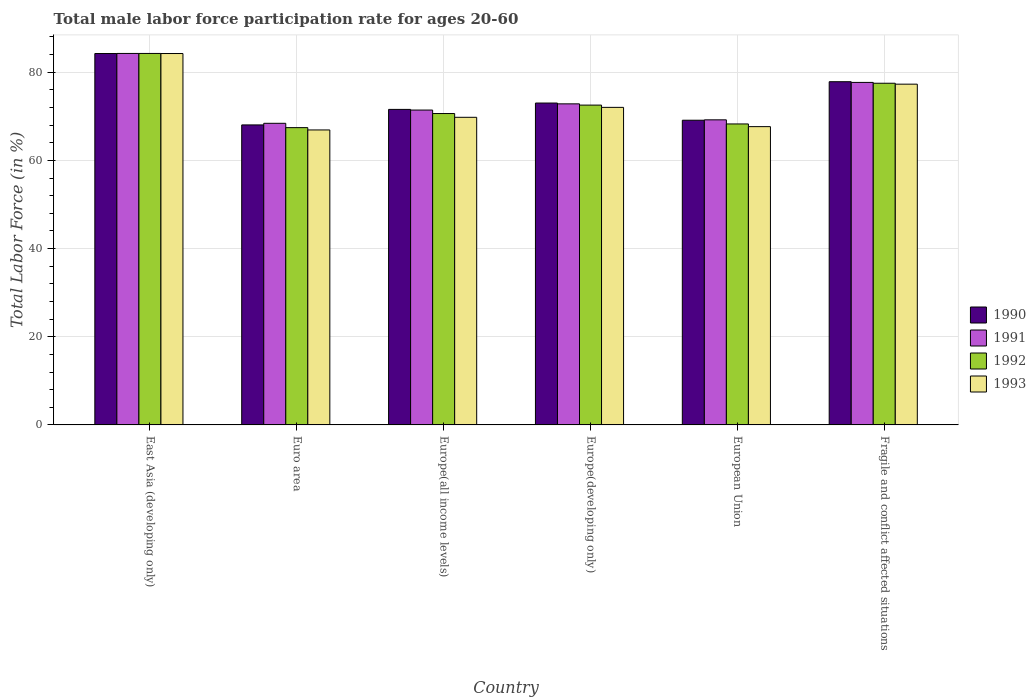How many groups of bars are there?
Your answer should be compact. 6. Are the number of bars per tick equal to the number of legend labels?
Your response must be concise. Yes. How many bars are there on the 6th tick from the left?
Offer a very short reply. 4. How many bars are there on the 6th tick from the right?
Make the answer very short. 4. What is the label of the 5th group of bars from the left?
Provide a succinct answer. European Union. What is the male labor force participation rate in 1991 in Europe(all income levels)?
Make the answer very short. 71.41. Across all countries, what is the maximum male labor force participation rate in 1991?
Your answer should be very brief. 84.25. Across all countries, what is the minimum male labor force participation rate in 1991?
Keep it short and to the point. 68.4. In which country was the male labor force participation rate in 1993 maximum?
Give a very brief answer. East Asia (developing only). What is the total male labor force participation rate in 1993 in the graph?
Ensure brevity in your answer.  437.85. What is the difference between the male labor force participation rate in 1990 in Europe(developing only) and that in Fragile and conflict affected situations?
Offer a very short reply. -4.84. What is the difference between the male labor force participation rate in 1991 in European Union and the male labor force participation rate in 1993 in Europe(all income levels)?
Your answer should be very brief. -0.57. What is the average male labor force participation rate in 1991 per country?
Ensure brevity in your answer.  73.96. What is the difference between the male labor force participation rate of/in 1993 and male labor force participation rate of/in 1992 in Europe(developing only)?
Ensure brevity in your answer.  -0.51. In how many countries, is the male labor force participation rate in 1993 greater than 64 %?
Keep it short and to the point. 6. What is the ratio of the male labor force participation rate in 1993 in East Asia (developing only) to that in Europe(developing only)?
Offer a terse response. 1.17. Is the difference between the male labor force participation rate in 1993 in Europe(developing only) and European Union greater than the difference between the male labor force participation rate in 1992 in Europe(developing only) and European Union?
Provide a short and direct response. Yes. What is the difference between the highest and the second highest male labor force participation rate in 1991?
Make the answer very short. -11.43. What is the difference between the highest and the lowest male labor force participation rate in 1990?
Make the answer very short. 16.19. Is it the case that in every country, the sum of the male labor force participation rate in 1990 and male labor force participation rate in 1993 is greater than the sum of male labor force participation rate in 1992 and male labor force participation rate in 1991?
Make the answer very short. No. How many bars are there?
Provide a short and direct response. 24. Are the values on the major ticks of Y-axis written in scientific E-notation?
Your answer should be compact. No. What is the title of the graph?
Keep it short and to the point. Total male labor force participation rate for ages 20-60. What is the label or title of the X-axis?
Provide a short and direct response. Country. What is the label or title of the Y-axis?
Provide a succinct answer. Total Labor Force (in %). What is the Total Labor Force (in %) of 1990 in East Asia (developing only)?
Make the answer very short. 84.23. What is the Total Labor Force (in %) in 1991 in East Asia (developing only)?
Provide a short and direct response. 84.25. What is the Total Labor Force (in %) of 1992 in East Asia (developing only)?
Ensure brevity in your answer.  84.25. What is the Total Labor Force (in %) of 1993 in East Asia (developing only)?
Provide a succinct answer. 84.23. What is the Total Labor Force (in %) in 1990 in Euro area?
Ensure brevity in your answer.  68.04. What is the Total Labor Force (in %) of 1991 in Euro area?
Make the answer very short. 68.4. What is the Total Labor Force (in %) of 1992 in Euro area?
Offer a terse response. 67.42. What is the Total Labor Force (in %) of 1993 in Euro area?
Keep it short and to the point. 66.9. What is the Total Labor Force (in %) in 1990 in Europe(all income levels)?
Provide a succinct answer. 71.56. What is the Total Labor Force (in %) of 1991 in Europe(all income levels)?
Give a very brief answer. 71.41. What is the Total Labor Force (in %) in 1992 in Europe(all income levels)?
Provide a short and direct response. 70.62. What is the Total Labor Force (in %) in 1993 in Europe(all income levels)?
Provide a succinct answer. 69.76. What is the Total Labor Force (in %) in 1990 in Europe(developing only)?
Make the answer very short. 73. What is the Total Labor Force (in %) of 1991 in Europe(developing only)?
Give a very brief answer. 72.82. What is the Total Labor Force (in %) in 1992 in Europe(developing only)?
Provide a succinct answer. 72.53. What is the Total Labor Force (in %) of 1993 in Europe(developing only)?
Ensure brevity in your answer.  72.02. What is the Total Labor Force (in %) of 1990 in European Union?
Make the answer very short. 69.1. What is the Total Labor Force (in %) in 1991 in European Union?
Give a very brief answer. 69.19. What is the Total Labor Force (in %) in 1992 in European Union?
Your response must be concise. 68.26. What is the Total Labor Force (in %) of 1993 in European Union?
Your response must be concise. 67.65. What is the Total Labor Force (in %) of 1990 in Fragile and conflict affected situations?
Keep it short and to the point. 77.84. What is the Total Labor Force (in %) of 1991 in Fragile and conflict affected situations?
Provide a short and direct response. 77.68. What is the Total Labor Force (in %) in 1992 in Fragile and conflict affected situations?
Your answer should be compact. 77.49. What is the Total Labor Force (in %) of 1993 in Fragile and conflict affected situations?
Your response must be concise. 77.28. Across all countries, what is the maximum Total Labor Force (in %) of 1990?
Offer a terse response. 84.23. Across all countries, what is the maximum Total Labor Force (in %) of 1991?
Provide a succinct answer. 84.25. Across all countries, what is the maximum Total Labor Force (in %) in 1992?
Ensure brevity in your answer.  84.25. Across all countries, what is the maximum Total Labor Force (in %) in 1993?
Your response must be concise. 84.23. Across all countries, what is the minimum Total Labor Force (in %) of 1990?
Provide a short and direct response. 68.04. Across all countries, what is the minimum Total Labor Force (in %) in 1991?
Ensure brevity in your answer.  68.4. Across all countries, what is the minimum Total Labor Force (in %) of 1992?
Your answer should be compact. 67.42. Across all countries, what is the minimum Total Labor Force (in %) of 1993?
Your response must be concise. 66.9. What is the total Total Labor Force (in %) in 1990 in the graph?
Your response must be concise. 443.78. What is the total Total Labor Force (in %) of 1991 in the graph?
Keep it short and to the point. 443.75. What is the total Total Labor Force (in %) in 1992 in the graph?
Your answer should be compact. 440.58. What is the total Total Labor Force (in %) of 1993 in the graph?
Offer a terse response. 437.85. What is the difference between the Total Labor Force (in %) of 1990 in East Asia (developing only) and that in Euro area?
Your answer should be very brief. 16.19. What is the difference between the Total Labor Force (in %) of 1991 in East Asia (developing only) and that in Euro area?
Make the answer very short. 15.84. What is the difference between the Total Labor Force (in %) of 1992 in East Asia (developing only) and that in Euro area?
Provide a short and direct response. 16.83. What is the difference between the Total Labor Force (in %) of 1993 in East Asia (developing only) and that in Euro area?
Your response must be concise. 17.34. What is the difference between the Total Labor Force (in %) of 1990 in East Asia (developing only) and that in Europe(all income levels)?
Offer a very short reply. 12.67. What is the difference between the Total Labor Force (in %) of 1991 in East Asia (developing only) and that in Europe(all income levels)?
Provide a succinct answer. 12.84. What is the difference between the Total Labor Force (in %) in 1992 in East Asia (developing only) and that in Europe(all income levels)?
Make the answer very short. 13.63. What is the difference between the Total Labor Force (in %) in 1993 in East Asia (developing only) and that in Europe(all income levels)?
Your answer should be very brief. 14.47. What is the difference between the Total Labor Force (in %) in 1990 in East Asia (developing only) and that in Europe(developing only)?
Provide a short and direct response. 11.23. What is the difference between the Total Labor Force (in %) of 1991 in East Asia (developing only) and that in Europe(developing only)?
Your response must be concise. 11.43. What is the difference between the Total Labor Force (in %) in 1992 in East Asia (developing only) and that in Europe(developing only)?
Give a very brief answer. 11.71. What is the difference between the Total Labor Force (in %) of 1993 in East Asia (developing only) and that in Europe(developing only)?
Your answer should be compact. 12.21. What is the difference between the Total Labor Force (in %) of 1990 in East Asia (developing only) and that in European Union?
Provide a short and direct response. 15.13. What is the difference between the Total Labor Force (in %) in 1991 in East Asia (developing only) and that in European Union?
Give a very brief answer. 15.05. What is the difference between the Total Labor Force (in %) of 1992 in East Asia (developing only) and that in European Union?
Your response must be concise. 15.99. What is the difference between the Total Labor Force (in %) in 1993 in East Asia (developing only) and that in European Union?
Your answer should be compact. 16.58. What is the difference between the Total Labor Force (in %) of 1990 in East Asia (developing only) and that in Fragile and conflict affected situations?
Ensure brevity in your answer.  6.39. What is the difference between the Total Labor Force (in %) in 1991 in East Asia (developing only) and that in Fragile and conflict affected situations?
Your response must be concise. 6.57. What is the difference between the Total Labor Force (in %) in 1992 in East Asia (developing only) and that in Fragile and conflict affected situations?
Ensure brevity in your answer.  6.76. What is the difference between the Total Labor Force (in %) of 1993 in East Asia (developing only) and that in Fragile and conflict affected situations?
Make the answer very short. 6.95. What is the difference between the Total Labor Force (in %) of 1990 in Euro area and that in Europe(all income levels)?
Keep it short and to the point. -3.52. What is the difference between the Total Labor Force (in %) of 1991 in Euro area and that in Europe(all income levels)?
Keep it short and to the point. -3. What is the difference between the Total Labor Force (in %) in 1992 in Euro area and that in Europe(all income levels)?
Your answer should be very brief. -3.2. What is the difference between the Total Labor Force (in %) of 1993 in Euro area and that in Europe(all income levels)?
Make the answer very short. -2.87. What is the difference between the Total Labor Force (in %) of 1990 in Euro area and that in Europe(developing only)?
Your response must be concise. -4.96. What is the difference between the Total Labor Force (in %) of 1991 in Euro area and that in Europe(developing only)?
Your response must be concise. -4.41. What is the difference between the Total Labor Force (in %) of 1992 in Euro area and that in Europe(developing only)?
Provide a succinct answer. -5.11. What is the difference between the Total Labor Force (in %) of 1993 in Euro area and that in Europe(developing only)?
Your answer should be very brief. -5.12. What is the difference between the Total Labor Force (in %) of 1990 in Euro area and that in European Union?
Your answer should be very brief. -1.06. What is the difference between the Total Labor Force (in %) of 1991 in Euro area and that in European Union?
Make the answer very short. -0.79. What is the difference between the Total Labor Force (in %) in 1992 in Euro area and that in European Union?
Offer a terse response. -0.83. What is the difference between the Total Labor Force (in %) in 1993 in Euro area and that in European Union?
Your response must be concise. -0.75. What is the difference between the Total Labor Force (in %) in 1990 in Euro area and that in Fragile and conflict affected situations?
Keep it short and to the point. -9.8. What is the difference between the Total Labor Force (in %) in 1991 in Euro area and that in Fragile and conflict affected situations?
Offer a terse response. -9.27. What is the difference between the Total Labor Force (in %) in 1992 in Euro area and that in Fragile and conflict affected situations?
Give a very brief answer. -10.07. What is the difference between the Total Labor Force (in %) in 1993 in Euro area and that in Fragile and conflict affected situations?
Provide a succinct answer. -10.38. What is the difference between the Total Labor Force (in %) in 1990 in Europe(all income levels) and that in Europe(developing only)?
Provide a short and direct response. -1.44. What is the difference between the Total Labor Force (in %) of 1991 in Europe(all income levels) and that in Europe(developing only)?
Ensure brevity in your answer.  -1.41. What is the difference between the Total Labor Force (in %) in 1992 in Europe(all income levels) and that in Europe(developing only)?
Your answer should be very brief. -1.91. What is the difference between the Total Labor Force (in %) of 1993 in Europe(all income levels) and that in Europe(developing only)?
Keep it short and to the point. -2.26. What is the difference between the Total Labor Force (in %) in 1990 in Europe(all income levels) and that in European Union?
Your answer should be very brief. 2.46. What is the difference between the Total Labor Force (in %) in 1991 in Europe(all income levels) and that in European Union?
Provide a short and direct response. 2.22. What is the difference between the Total Labor Force (in %) in 1992 in Europe(all income levels) and that in European Union?
Give a very brief answer. 2.36. What is the difference between the Total Labor Force (in %) of 1993 in Europe(all income levels) and that in European Union?
Your response must be concise. 2.11. What is the difference between the Total Labor Force (in %) of 1990 in Europe(all income levels) and that in Fragile and conflict affected situations?
Offer a terse response. -6.28. What is the difference between the Total Labor Force (in %) in 1991 in Europe(all income levels) and that in Fragile and conflict affected situations?
Provide a succinct answer. -6.27. What is the difference between the Total Labor Force (in %) of 1992 in Europe(all income levels) and that in Fragile and conflict affected situations?
Offer a very short reply. -6.87. What is the difference between the Total Labor Force (in %) of 1993 in Europe(all income levels) and that in Fragile and conflict affected situations?
Ensure brevity in your answer.  -7.52. What is the difference between the Total Labor Force (in %) in 1990 in Europe(developing only) and that in European Union?
Your response must be concise. 3.9. What is the difference between the Total Labor Force (in %) in 1991 in Europe(developing only) and that in European Union?
Give a very brief answer. 3.62. What is the difference between the Total Labor Force (in %) of 1992 in Europe(developing only) and that in European Union?
Ensure brevity in your answer.  4.28. What is the difference between the Total Labor Force (in %) of 1993 in Europe(developing only) and that in European Union?
Give a very brief answer. 4.37. What is the difference between the Total Labor Force (in %) in 1990 in Europe(developing only) and that in Fragile and conflict affected situations?
Your answer should be compact. -4.84. What is the difference between the Total Labor Force (in %) of 1991 in Europe(developing only) and that in Fragile and conflict affected situations?
Your answer should be compact. -4.86. What is the difference between the Total Labor Force (in %) in 1992 in Europe(developing only) and that in Fragile and conflict affected situations?
Provide a succinct answer. -4.96. What is the difference between the Total Labor Force (in %) in 1993 in Europe(developing only) and that in Fragile and conflict affected situations?
Your response must be concise. -5.26. What is the difference between the Total Labor Force (in %) in 1990 in European Union and that in Fragile and conflict affected situations?
Your response must be concise. -8.73. What is the difference between the Total Labor Force (in %) in 1991 in European Union and that in Fragile and conflict affected situations?
Offer a very short reply. -8.49. What is the difference between the Total Labor Force (in %) of 1992 in European Union and that in Fragile and conflict affected situations?
Ensure brevity in your answer.  -9.23. What is the difference between the Total Labor Force (in %) of 1993 in European Union and that in Fragile and conflict affected situations?
Give a very brief answer. -9.63. What is the difference between the Total Labor Force (in %) in 1990 in East Asia (developing only) and the Total Labor Force (in %) in 1991 in Euro area?
Your answer should be compact. 15.83. What is the difference between the Total Labor Force (in %) of 1990 in East Asia (developing only) and the Total Labor Force (in %) of 1992 in Euro area?
Offer a terse response. 16.81. What is the difference between the Total Labor Force (in %) in 1990 in East Asia (developing only) and the Total Labor Force (in %) in 1993 in Euro area?
Offer a terse response. 17.34. What is the difference between the Total Labor Force (in %) in 1991 in East Asia (developing only) and the Total Labor Force (in %) in 1992 in Euro area?
Your response must be concise. 16.82. What is the difference between the Total Labor Force (in %) in 1991 in East Asia (developing only) and the Total Labor Force (in %) in 1993 in Euro area?
Keep it short and to the point. 17.35. What is the difference between the Total Labor Force (in %) in 1992 in East Asia (developing only) and the Total Labor Force (in %) in 1993 in Euro area?
Offer a very short reply. 17.35. What is the difference between the Total Labor Force (in %) in 1990 in East Asia (developing only) and the Total Labor Force (in %) in 1991 in Europe(all income levels)?
Your answer should be compact. 12.82. What is the difference between the Total Labor Force (in %) in 1990 in East Asia (developing only) and the Total Labor Force (in %) in 1992 in Europe(all income levels)?
Your answer should be compact. 13.61. What is the difference between the Total Labor Force (in %) in 1990 in East Asia (developing only) and the Total Labor Force (in %) in 1993 in Europe(all income levels)?
Provide a short and direct response. 14.47. What is the difference between the Total Labor Force (in %) of 1991 in East Asia (developing only) and the Total Labor Force (in %) of 1992 in Europe(all income levels)?
Your answer should be compact. 13.63. What is the difference between the Total Labor Force (in %) of 1991 in East Asia (developing only) and the Total Labor Force (in %) of 1993 in Europe(all income levels)?
Provide a succinct answer. 14.48. What is the difference between the Total Labor Force (in %) in 1992 in East Asia (developing only) and the Total Labor Force (in %) in 1993 in Europe(all income levels)?
Keep it short and to the point. 14.48. What is the difference between the Total Labor Force (in %) of 1990 in East Asia (developing only) and the Total Labor Force (in %) of 1991 in Europe(developing only)?
Your answer should be compact. 11.42. What is the difference between the Total Labor Force (in %) in 1990 in East Asia (developing only) and the Total Labor Force (in %) in 1992 in Europe(developing only)?
Make the answer very short. 11.7. What is the difference between the Total Labor Force (in %) of 1990 in East Asia (developing only) and the Total Labor Force (in %) of 1993 in Europe(developing only)?
Keep it short and to the point. 12.21. What is the difference between the Total Labor Force (in %) of 1991 in East Asia (developing only) and the Total Labor Force (in %) of 1992 in Europe(developing only)?
Your answer should be very brief. 11.71. What is the difference between the Total Labor Force (in %) of 1991 in East Asia (developing only) and the Total Labor Force (in %) of 1993 in Europe(developing only)?
Your answer should be compact. 12.23. What is the difference between the Total Labor Force (in %) of 1992 in East Asia (developing only) and the Total Labor Force (in %) of 1993 in Europe(developing only)?
Offer a terse response. 12.23. What is the difference between the Total Labor Force (in %) of 1990 in East Asia (developing only) and the Total Labor Force (in %) of 1991 in European Union?
Make the answer very short. 15.04. What is the difference between the Total Labor Force (in %) of 1990 in East Asia (developing only) and the Total Labor Force (in %) of 1992 in European Union?
Your answer should be compact. 15.97. What is the difference between the Total Labor Force (in %) of 1990 in East Asia (developing only) and the Total Labor Force (in %) of 1993 in European Union?
Your response must be concise. 16.58. What is the difference between the Total Labor Force (in %) in 1991 in East Asia (developing only) and the Total Labor Force (in %) in 1992 in European Union?
Your answer should be compact. 15.99. What is the difference between the Total Labor Force (in %) of 1991 in East Asia (developing only) and the Total Labor Force (in %) of 1993 in European Union?
Your answer should be compact. 16.6. What is the difference between the Total Labor Force (in %) in 1992 in East Asia (developing only) and the Total Labor Force (in %) in 1993 in European Union?
Give a very brief answer. 16.6. What is the difference between the Total Labor Force (in %) of 1990 in East Asia (developing only) and the Total Labor Force (in %) of 1991 in Fragile and conflict affected situations?
Give a very brief answer. 6.55. What is the difference between the Total Labor Force (in %) in 1990 in East Asia (developing only) and the Total Labor Force (in %) in 1992 in Fragile and conflict affected situations?
Your response must be concise. 6.74. What is the difference between the Total Labor Force (in %) in 1990 in East Asia (developing only) and the Total Labor Force (in %) in 1993 in Fragile and conflict affected situations?
Your response must be concise. 6.95. What is the difference between the Total Labor Force (in %) in 1991 in East Asia (developing only) and the Total Labor Force (in %) in 1992 in Fragile and conflict affected situations?
Keep it short and to the point. 6.76. What is the difference between the Total Labor Force (in %) of 1991 in East Asia (developing only) and the Total Labor Force (in %) of 1993 in Fragile and conflict affected situations?
Your response must be concise. 6.97. What is the difference between the Total Labor Force (in %) of 1992 in East Asia (developing only) and the Total Labor Force (in %) of 1993 in Fragile and conflict affected situations?
Make the answer very short. 6.97. What is the difference between the Total Labor Force (in %) in 1990 in Euro area and the Total Labor Force (in %) in 1991 in Europe(all income levels)?
Keep it short and to the point. -3.37. What is the difference between the Total Labor Force (in %) in 1990 in Euro area and the Total Labor Force (in %) in 1992 in Europe(all income levels)?
Give a very brief answer. -2.58. What is the difference between the Total Labor Force (in %) in 1990 in Euro area and the Total Labor Force (in %) in 1993 in Europe(all income levels)?
Make the answer very short. -1.72. What is the difference between the Total Labor Force (in %) of 1991 in Euro area and the Total Labor Force (in %) of 1992 in Europe(all income levels)?
Keep it short and to the point. -2.22. What is the difference between the Total Labor Force (in %) in 1991 in Euro area and the Total Labor Force (in %) in 1993 in Europe(all income levels)?
Make the answer very short. -1.36. What is the difference between the Total Labor Force (in %) in 1992 in Euro area and the Total Labor Force (in %) in 1993 in Europe(all income levels)?
Your response must be concise. -2.34. What is the difference between the Total Labor Force (in %) of 1990 in Euro area and the Total Labor Force (in %) of 1991 in Europe(developing only)?
Your answer should be very brief. -4.78. What is the difference between the Total Labor Force (in %) of 1990 in Euro area and the Total Labor Force (in %) of 1992 in Europe(developing only)?
Offer a terse response. -4.49. What is the difference between the Total Labor Force (in %) of 1990 in Euro area and the Total Labor Force (in %) of 1993 in Europe(developing only)?
Offer a terse response. -3.98. What is the difference between the Total Labor Force (in %) of 1991 in Euro area and the Total Labor Force (in %) of 1992 in Europe(developing only)?
Your answer should be very brief. -4.13. What is the difference between the Total Labor Force (in %) in 1991 in Euro area and the Total Labor Force (in %) in 1993 in Europe(developing only)?
Ensure brevity in your answer.  -3.62. What is the difference between the Total Labor Force (in %) in 1992 in Euro area and the Total Labor Force (in %) in 1993 in Europe(developing only)?
Give a very brief answer. -4.6. What is the difference between the Total Labor Force (in %) in 1990 in Euro area and the Total Labor Force (in %) in 1991 in European Union?
Ensure brevity in your answer.  -1.15. What is the difference between the Total Labor Force (in %) in 1990 in Euro area and the Total Labor Force (in %) in 1992 in European Union?
Make the answer very short. -0.22. What is the difference between the Total Labor Force (in %) in 1990 in Euro area and the Total Labor Force (in %) in 1993 in European Union?
Provide a short and direct response. 0.39. What is the difference between the Total Labor Force (in %) in 1991 in Euro area and the Total Labor Force (in %) in 1992 in European Union?
Keep it short and to the point. 0.15. What is the difference between the Total Labor Force (in %) of 1991 in Euro area and the Total Labor Force (in %) of 1993 in European Union?
Keep it short and to the point. 0.75. What is the difference between the Total Labor Force (in %) of 1992 in Euro area and the Total Labor Force (in %) of 1993 in European Union?
Your answer should be very brief. -0.23. What is the difference between the Total Labor Force (in %) in 1990 in Euro area and the Total Labor Force (in %) in 1991 in Fragile and conflict affected situations?
Your response must be concise. -9.64. What is the difference between the Total Labor Force (in %) of 1990 in Euro area and the Total Labor Force (in %) of 1992 in Fragile and conflict affected situations?
Keep it short and to the point. -9.45. What is the difference between the Total Labor Force (in %) of 1990 in Euro area and the Total Labor Force (in %) of 1993 in Fragile and conflict affected situations?
Keep it short and to the point. -9.24. What is the difference between the Total Labor Force (in %) in 1991 in Euro area and the Total Labor Force (in %) in 1992 in Fragile and conflict affected situations?
Your answer should be compact. -9.09. What is the difference between the Total Labor Force (in %) of 1991 in Euro area and the Total Labor Force (in %) of 1993 in Fragile and conflict affected situations?
Keep it short and to the point. -8.88. What is the difference between the Total Labor Force (in %) of 1992 in Euro area and the Total Labor Force (in %) of 1993 in Fragile and conflict affected situations?
Give a very brief answer. -9.86. What is the difference between the Total Labor Force (in %) of 1990 in Europe(all income levels) and the Total Labor Force (in %) of 1991 in Europe(developing only)?
Make the answer very short. -1.26. What is the difference between the Total Labor Force (in %) of 1990 in Europe(all income levels) and the Total Labor Force (in %) of 1992 in Europe(developing only)?
Offer a terse response. -0.97. What is the difference between the Total Labor Force (in %) in 1990 in Europe(all income levels) and the Total Labor Force (in %) in 1993 in Europe(developing only)?
Your response must be concise. -0.46. What is the difference between the Total Labor Force (in %) in 1991 in Europe(all income levels) and the Total Labor Force (in %) in 1992 in Europe(developing only)?
Keep it short and to the point. -1.12. What is the difference between the Total Labor Force (in %) in 1991 in Europe(all income levels) and the Total Labor Force (in %) in 1993 in Europe(developing only)?
Ensure brevity in your answer.  -0.61. What is the difference between the Total Labor Force (in %) in 1992 in Europe(all income levels) and the Total Labor Force (in %) in 1993 in Europe(developing only)?
Give a very brief answer. -1.4. What is the difference between the Total Labor Force (in %) of 1990 in Europe(all income levels) and the Total Labor Force (in %) of 1991 in European Union?
Offer a terse response. 2.37. What is the difference between the Total Labor Force (in %) in 1990 in Europe(all income levels) and the Total Labor Force (in %) in 1992 in European Union?
Provide a short and direct response. 3.3. What is the difference between the Total Labor Force (in %) of 1990 in Europe(all income levels) and the Total Labor Force (in %) of 1993 in European Union?
Make the answer very short. 3.91. What is the difference between the Total Labor Force (in %) of 1991 in Europe(all income levels) and the Total Labor Force (in %) of 1992 in European Union?
Keep it short and to the point. 3.15. What is the difference between the Total Labor Force (in %) of 1991 in Europe(all income levels) and the Total Labor Force (in %) of 1993 in European Union?
Provide a succinct answer. 3.76. What is the difference between the Total Labor Force (in %) of 1992 in Europe(all income levels) and the Total Labor Force (in %) of 1993 in European Union?
Make the answer very short. 2.97. What is the difference between the Total Labor Force (in %) of 1990 in Europe(all income levels) and the Total Labor Force (in %) of 1991 in Fragile and conflict affected situations?
Your answer should be very brief. -6.12. What is the difference between the Total Labor Force (in %) in 1990 in Europe(all income levels) and the Total Labor Force (in %) in 1992 in Fragile and conflict affected situations?
Your response must be concise. -5.93. What is the difference between the Total Labor Force (in %) of 1990 in Europe(all income levels) and the Total Labor Force (in %) of 1993 in Fragile and conflict affected situations?
Your answer should be compact. -5.72. What is the difference between the Total Labor Force (in %) in 1991 in Europe(all income levels) and the Total Labor Force (in %) in 1992 in Fragile and conflict affected situations?
Provide a succinct answer. -6.08. What is the difference between the Total Labor Force (in %) of 1991 in Europe(all income levels) and the Total Labor Force (in %) of 1993 in Fragile and conflict affected situations?
Your answer should be compact. -5.87. What is the difference between the Total Labor Force (in %) of 1992 in Europe(all income levels) and the Total Labor Force (in %) of 1993 in Fragile and conflict affected situations?
Give a very brief answer. -6.66. What is the difference between the Total Labor Force (in %) of 1990 in Europe(developing only) and the Total Labor Force (in %) of 1991 in European Union?
Your answer should be compact. 3.81. What is the difference between the Total Labor Force (in %) of 1990 in Europe(developing only) and the Total Labor Force (in %) of 1992 in European Union?
Your response must be concise. 4.74. What is the difference between the Total Labor Force (in %) of 1990 in Europe(developing only) and the Total Labor Force (in %) of 1993 in European Union?
Provide a succinct answer. 5.35. What is the difference between the Total Labor Force (in %) in 1991 in Europe(developing only) and the Total Labor Force (in %) in 1992 in European Union?
Give a very brief answer. 4.56. What is the difference between the Total Labor Force (in %) in 1991 in Europe(developing only) and the Total Labor Force (in %) in 1993 in European Union?
Provide a succinct answer. 5.17. What is the difference between the Total Labor Force (in %) in 1992 in Europe(developing only) and the Total Labor Force (in %) in 1993 in European Union?
Make the answer very short. 4.88. What is the difference between the Total Labor Force (in %) in 1990 in Europe(developing only) and the Total Labor Force (in %) in 1991 in Fragile and conflict affected situations?
Provide a short and direct response. -4.68. What is the difference between the Total Labor Force (in %) in 1990 in Europe(developing only) and the Total Labor Force (in %) in 1992 in Fragile and conflict affected situations?
Provide a short and direct response. -4.49. What is the difference between the Total Labor Force (in %) in 1990 in Europe(developing only) and the Total Labor Force (in %) in 1993 in Fragile and conflict affected situations?
Provide a short and direct response. -4.28. What is the difference between the Total Labor Force (in %) in 1991 in Europe(developing only) and the Total Labor Force (in %) in 1992 in Fragile and conflict affected situations?
Make the answer very short. -4.68. What is the difference between the Total Labor Force (in %) of 1991 in Europe(developing only) and the Total Labor Force (in %) of 1993 in Fragile and conflict affected situations?
Make the answer very short. -4.47. What is the difference between the Total Labor Force (in %) in 1992 in Europe(developing only) and the Total Labor Force (in %) in 1993 in Fragile and conflict affected situations?
Provide a succinct answer. -4.75. What is the difference between the Total Labor Force (in %) of 1990 in European Union and the Total Labor Force (in %) of 1991 in Fragile and conflict affected situations?
Your answer should be very brief. -8.58. What is the difference between the Total Labor Force (in %) of 1990 in European Union and the Total Labor Force (in %) of 1992 in Fragile and conflict affected situations?
Ensure brevity in your answer.  -8.39. What is the difference between the Total Labor Force (in %) in 1990 in European Union and the Total Labor Force (in %) in 1993 in Fragile and conflict affected situations?
Offer a terse response. -8.18. What is the difference between the Total Labor Force (in %) of 1991 in European Union and the Total Labor Force (in %) of 1992 in Fragile and conflict affected situations?
Provide a short and direct response. -8.3. What is the difference between the Total Labor Force (in %) of 1991 in European Union and the Total Labor Force (in %) of 1993 in Fragile and conflict affected situations?
Your answer should be compact. -8.09. What is the difference between the Total Labor Force (in %) of 1992 in European Union and the Total Labor Force (in %) of 1993 in Fragile and conflict affected situations?
Provide a short and direct response. -9.02. What is the average Total Labor Force (in %) in 1990 per country?
Offer a terse response. 73.96. What is the average Total Labor Force (in %) of 1991 per country?
Make the answer very short. 73.96. What is the average Total Labor Force (in %) in 1992 per country?
Your answer should be compact. 73.43. What is the average Total Labor Force (in %) in 1993 per country?
Your answer should be very brief. 72.97. What is the difference between the Total Labor Force (in %) in 1990 and Total Labor Force (in %) in 1991 in East Asia (developing only)?
Your answer should be compact. -0.02. What is the difference between the Total Labor Force (in %) in 1990 and Total Labor Force (in %) in 1992 in East Asia (developing only)?
Keep it short and to the point. -0.02. What is the difference between the Total Labor Force (in %) of 1990 and Total Labor Force (in %) of 1993 in East Asia (developing only)?
Your answer should be compact. -0. What is the difference between the Total Labor Force (in %) in 1991 and Total Labor Force (in %) in 1992 in East Asia (developing only)?
Keep it short and to the point. -0. What is the difference between the Total Labor Force (in %) of 1991 and Total Labor Force (in %) of 1993 in East Asia (developing only)?
Your answer should be very brief. 0.01. What is the difference between the Total Labor Force (in %) of 1992 and Total Labor Force (in %) of 1993 in East Asia (developing only)?
Provide a succinct answer. 0.02. What is the difference between the Total Labor Force (in %) of 1990 and Total Labor Force (in %) of 1991 in Euro area?
Keep it short and to the point. -0.36. What is the difference between the Total Labor Force (in %) in 1990 and Total Labor Force (in %) in 1992 in Euro area?
Provide a short and direct response. 0.62. What is the difference between the Total Labor Force (in %) in 1990 and Total Labor Force (in %) in 1993 in Euro area?
Give a very brief answer. 1.14. What is the difference between the Total Labor Force (in %) of 1991 and Total Labor Force (in %) of 1993 in Euro area?
Your response must be concise. 1.51. What is the difference between the Total Labor Force (in %) in 1992 and Total Labor Force (in %) in 1993 in Euro area?
Keep it short and to the point. 0.53. What is the difference between the Total Labor Force (in %) in 1990 and Total Labor Force (in %) in 1991 in Europe(all income levels)?
Ensure brevity in your answer.  0.15. What is the difference between the Total Labor Force (in %) of 1990 and Total Labor Force (in %) of 1992 in Europe(all income levels)?
Give a very brief answer. 0.94. What is the difference between the Total Labor Force (in %) in 1990 and Total Labor Force (in %) in 1993 in Europe(all income levels)?
Keep it short and to the point. 1.8. What is the difference between the Total Labor Force (in %) of 1991 and Total Labor Force (in %) of 1992 in Europe(all income levels)?
Your answer should be very brief. 0.79. What is the difference between the Total Labor Force (in %) in 1991 and Total Labor Force (in %) in 1993 in Europe(all income levels)?
Your response must be concise. 1.64. What is the difference between the Total Labor Force (in %) of 1992 and Total Labor Force (in %) of 1993 in Europe(all income levels)?
Your answer should be compact. 0.86. What is the difference between the Total Labor Force (in %) in 1990 and Total Labor Force (in %) in 1991 in Europe(developing only)?
Provide a succinct answer. 0.18. What is the difference between the Total Labor Force (in %) of 1990 and Total Labor Force (in %) of 1992 in Europe(developing only)?
Keep it short and to the point. 0.47. What is the difference between the Total Labor Force (in %) of 1990 and Total Labor Force (in %) of 1993 in Europe(developing only)?
Offer a very short reply. 0.98. What is the difference between the Total Labor Force (in %) in 1991 and Total Labor Force (in %) in 1992 in Europe(developing only)?
Make the answer very short. 0.28. What is the difference between the Total Labor Force (in %) in 1991 and Total Labor Force (in %) in 1993 in Europe(developing only)?
Offer a terse response. 0.79. What is the difference between the Total Labor Force (in %) in 1992 and Total Labor Force (in %) in 1993 in Europe(developing only)?
Provide a succinct answer. 0.51. What is the difference between the Total Labor Force (in %) in 1990 and Total Labor Force (in %) in 1991 in European Union?
Make the answer very short. -0.09. What is the difference between the Total Labor Force (in %) of 1990 and Total Labor Force (in %) of 1992 in European Union?
Give a very brief answer. 0.85. What is the difference between the Total Labor Force (in %) in 1990 and Total Labor Force (in %) in 1993 in European Union?
Your response must be concise. 1.45. What is the difference between the Total Labor Force (in %) in 1991 and Total Labor Force (in %) in 1992 in European Union?
Give a very brief answer. 0.93. What is the difference between the Total Labor Force (in %) in 1991 and Total Labor Force (in %) in 1993 in European Union?
Your answer should be compact. 1.54. What is the difference between the Total Labor Force (in %) of 1992 and Total Labor Force (in %) of 1993 in European Union?
Provide a succinct answer. 0.61. What is the difference between the Total Labor Force (in %) in 1990 and Total Labor Force (in %) in 1991 in Fragile and conflict affected situations?
Provide a succinct answer. 0.16. What is the difference between the Total Labor Force (in %) of 1990 and Total Labor Force (in %) of 1992 in Fragile and conflict affected situations?
Make the answer very short. 0.35. What is the difference between the Total Labor Force (in %) of 1990 and Total Labor Force (in %) of 1993 in Fragile and conflict affected situations?
Offer a terse response. 0.56. What is the difference between the Total Labor Force (in %) of 1991 and Total Labor Force (in %) of 1992 in Fragile and conflict affected situations?
Your response must be concise. 0.19. What is the difference between the Total Labor Force (in %) in 1991 and Total Labor Force (in %) in 1993 in Fragile and conflict affected situations?
Ensure brevity in your answer.  0.4. What is the difference between the Total Labor Force (in %) in 1992 and Total Labor Force (in %) in 1993 in Fragile and conflict affected situations?
Give a very brief answer. 0.21. What is the ratio of the Total Labor Force (in %) of 1990 in East Asia (developing only) to that in Euro area?
Your response must be concise. 1.24. What is the ratio of the Total Labor Force (in %) of 1991 in East Asia (developing only) to that in Euro area?
Offer a very short reply. 1.23. What is the ratio of the Total Labor Force (in %) in 1992 in East Asia (developing only) to that in Euro area?
Your response must be concise. 1.25. What is the ratio of the Total Labor Force (in %) of 1993 in East Asia (developing only) to that in Euro area?
Make the answer very short. 1.26. What is the ratio of the Total Labor Force (in %) of 1990 in East Asia (developing only) to that in Europe(all income levels)?
Ensure brevity in your answer.  1.18. What is the ratio of the Total Labor Force (in %) in 1991 in East Asia (developing only) to that in Europe(all income levels)?
Your answer should be very brief. 1.18. What is the ratio of the Total Labor Force (in %) of 1992 in East Asia (developing only) to that in Europe(all income levels)?
Your answer should be very brief. 1.19. What is the ratio of the Total Labor Force (in %) of 1993 in East Asia (developing only) to that in Europe(all income levels)?
Your answer should be very brief. 1.21. What is the ratio of the Total Labor Force (in %) in 1990 in East Asia (developing only) to that in Europe(developing only)?
Provide a short and direct response. 1.15. What is the ratio of the Total Labor Force (in %) of 1991 in East Asia (developing only) to that in Europe(developing only)?
Keep it short and to the point. 1.16. What is the ratio of the Total Labor Force (in %) of 1992 in East Asia (developing only) to that in Europe(developing only)?
Offer a terse response. 1.16. What is the ratio of the Total Labor Force (in %) of 1993 in East Asia (developing only) to that in Europe(developing only)?
Ensure brevity in your answer.  1.17. What is the ratio of the Total Labor Force (in %) in 1990 in East Asia (developing only) to that in European Union?
Provide a succinct answer. 1.22. What is the ratio of the Total Labor Force (in %) in 1991 in East Asia (developing only) to that in European Union?
Provide a short and direct response. 1.22. What is the ratio of the Total Labor Force (in %) in 1992 in East Asia (developing only) to that in European Union?
Provide a short and direct response. 1.23. What is the ratio of the Total Labor Force (in %) in 1993 in East Asia (developing only) to that in European Union?
Make the answer very short. 1.25. What is the ratio of the Total Labor Force (in %) in 1990 in East Asia (developing only) to that in Fragile and conflict affected situations?
Keep it short and to the point. 1.08. What is the ratio of the Total Labor Force (in %) in 1991 in East Asia (developing only) to that in Fragile and conflict affected situations?
Give a very brief answer. 1.08. What is the ratio of the Total Labor Force (in %) in 1992 in East Asia (developing only) to that in Fragile and conflict affected situations?
Provide a short and direct response. 1.09. What is the ratio of the Total Labor Force (in %) of 1993 in East Asia (developing only) to that in Fragile and conflict affected situations?
Offer a terse response. 1.09. What is the ratio of the Total Labor Force (in %) in 1990 in Euro area to that in Europe(all income levels)?
Provide a short and direct response. 0.95. What is the ratio of the Total Labor Force (in %) of 1991 in Euro area to that in Europe(all income levels)?
Ensure brevity in your answer.  0.96. What is the ratio of the Total Labor Force (in %) of 1992 in Euro area to that in Europe(all income levels)?
Provide a succinct answer. 0.95. What is the ratio of the Total Labor Force (in %) of 1993 in Euro area to that in Europe(all income levels)?
Provide a succinct answer. 0.96. What is the ratio of the Total Labor Force (in %) of 1990 in Euro area to that in Europe(developing only)?
Make the answer very short. 0.93. What is the ratio of the Total Labor Force (in %) in 1991 in Euro area to that in Europe(developing only)?
Provide a succinct answer. 0.94. What is the ratio of the Total Labor Force (in %) in 1992 in Euro area to that in Europe(developing only)?
Your answer should be very brief. 0.93. What is the ratio of the Total Labor Force (in %) of 1993 in Euro area to that in Europe(developing only)?
Provide a succinct answer. 0.93. What is the ratio of the Total Labor Force (in %) in 1990 in Euro area to that in European Union?
Offer a terse response. 0.98. What is the ratio of the Total Labor Force (in %) of 1992 in Euro area to that in European Union?
Your answer should be compact. 0.99. What is the ratio of the Total Labor Force (in %) in 1993 in Euro area to that in European Union?
Give a very brief answer. 0.99. What is the ratio of the Total Labor Force (in %) in 1990 in Euro area to that in Fragile and conflict affected situations?
Your answer should be compact. 0.87. What is the ratio of the Total Labor Force (in %) in 1991 in Euro area to that in Fragile and conflict affected situations?
Keep it short and to the point. 0.88. What is the ratio of the Total Labor Force (in %) in 1992 in Euro area to that in Fragile and conflict affected situations?
Offer a very short reply. 0.87. What is the ratio of the Total Labor Force (in %) of 1993 in Euro area to that in Fragile and conflict affected situations?
Ensure brevity in your answer.  0.87. What is the ratio of the Total Labor Force (in %) of 1990 in Europe(all income levels) to that in Europe(developing only)?
Make the answer very short. 0.98. What is the ratio of the Total Labor Force (in %) of 1991 in Europe(all income levels) to that in Europe(developing only)?
Make the answer very short. 0.98. What is the ratio of the Total Labor Force (in %) of 1992 in Europe(all income levels) to that in Europe(developing only)?
Give a very brief answer. 0.97. What is the ratio of the Total Labor Force (in %) in 1993 in Europe(all income levels) to that in Europe(developing only)?
Offer a terse response. 0.97. What is the ratio of the Total Labor Force (in %) of 1990 in Europe(all income levels) to that in European Union?
Your answer should be compact. 1.04. What is the ratio of the Total Labor Force (in %) of 1991 in Europe(all income levels) to that in European Union?
Ensure brevity in your answer.  1.03. What is the ratio of the Total Labor Force (in %) in 1992 in Europe(all income levels) to that in European Union?
Keep it short and to the point. 1.03. What is the ratio of the Total Labor Force (in %) of 1993 in Europe(all income levels) to that in European Union?
Provide a succinct answer. 1.03. What is the ratio of the Total Labor Force (in %) of 1990 in Europe(all income levels) to that in Fragile and conflict affected situations?
Your answer should be very brief. 0.92. What is the ratio of the Total Labor Force (in %) of 1991 in Europe(all income levels) to that in Fragile and conflict affected situations?
Provide a succinct answer. 0.92. What is the ratio of the Total Labor Force (in %) in 1992 in Europe(all income levels) to that in Fragile and conflict affected situations?
Offer a terse response. 0.91. What is the ratio of the Total Labor Force (in %) in 1993 in Europe(all income levels) to that in Fragile and conflict affected situations?
Ensure brevity in your answer.  0.9. What is the ratio of the Total Labor Force (in %) of 1990 in Europe(developing only) to that in European Union?
Ensure brevity in your answer.  1.06. What is the ratio of the Total Labor Force (in %) of 1991 in Europe(developing only) to that in European Union?
Provide a succinct answer. 1.05. What is the ratio of the Total Labor Force (in %) of 1992 in Europe(developing only) to that in European Union?
Your answer should be compact. 1.06. What is the ratio of the Total Labor Force (in %) in 1993 in Europe(developing only) to that in European Union?
Provide a short and direct response. 1.06. What is the ratio of the Total Labor Force (in %) of 1990 in Europe(developing only) to that in Fragile and conflict affected situations?
Make the answer very short. 0.94. What is the ratio of the Total Labor Force (in %) in 1991 in Europe(developing only) to that in Fragile and conflict affected situations?
Keep it short and to the point. 0.94. What is the ratio of the Total Labor Force (in %) in 1992 in Europe(developing only) to that in Fragile and conflict affected situations?
Give a very brief answer. 0.94. What is the ratio of the Total Labor Force (in %) of 1993 in Europe(developing only) to that in Fragile and conflict affected situations?
Offer a terse response. 0.93. What is the ratio of the Total Labor Force (in %) of 1990 in European Union to that in Fragile and conflict affected situations?
Offer a very short reply. 0.89. What is the ratio of the Total Labor Force (in %) in 1991 in European Union to that in Fragile and conflict affected situations?
Ensure brevity in your answer.  0.89. What is the ratio of the Total Labor Force (in %) of 1992 in European Union to that in Fragile and conflict affected situations?
Provide a succinct answer. 0.88. What is the ratio of the Total Labor Force (in %) in 1993 in European Union to that in Fragile and conflict affected situations?
Provide a short and direct response. 0.88. What is the difference between the highest and the second highest Total Labor Force (in %) in 1990?
Make the answer very short. 6.39. What is the difference between the highest and the second highest Total Labor Force (in %) of 1991?
Provide a short and direct response. 6.57. What is the difference between the highest and the second highest Total Labor Force (in %) of 1992?
Give a very brief answer. 6.76. What is the difference between the highest and the second highest Total Labor Force (in %) of 1993?
Offer a terse response. 6.95. What is the difference between the highest and the lowest Total Labor Force (in %) in 1990?
Provide a succinct answer. 16.19. What is the difference between the highest and the lowest Total Labor Force (in %) in 1991?
Your answer should be compact. 15.84. What is the difference between the highest and the lowest Total Labor Force (in %) in 1992?
Offer a very short reply. 16.83. What is the difference between the highest and the lowest Total Labor Force (in %) of 1993?
Offer a terse response. 17.34. 